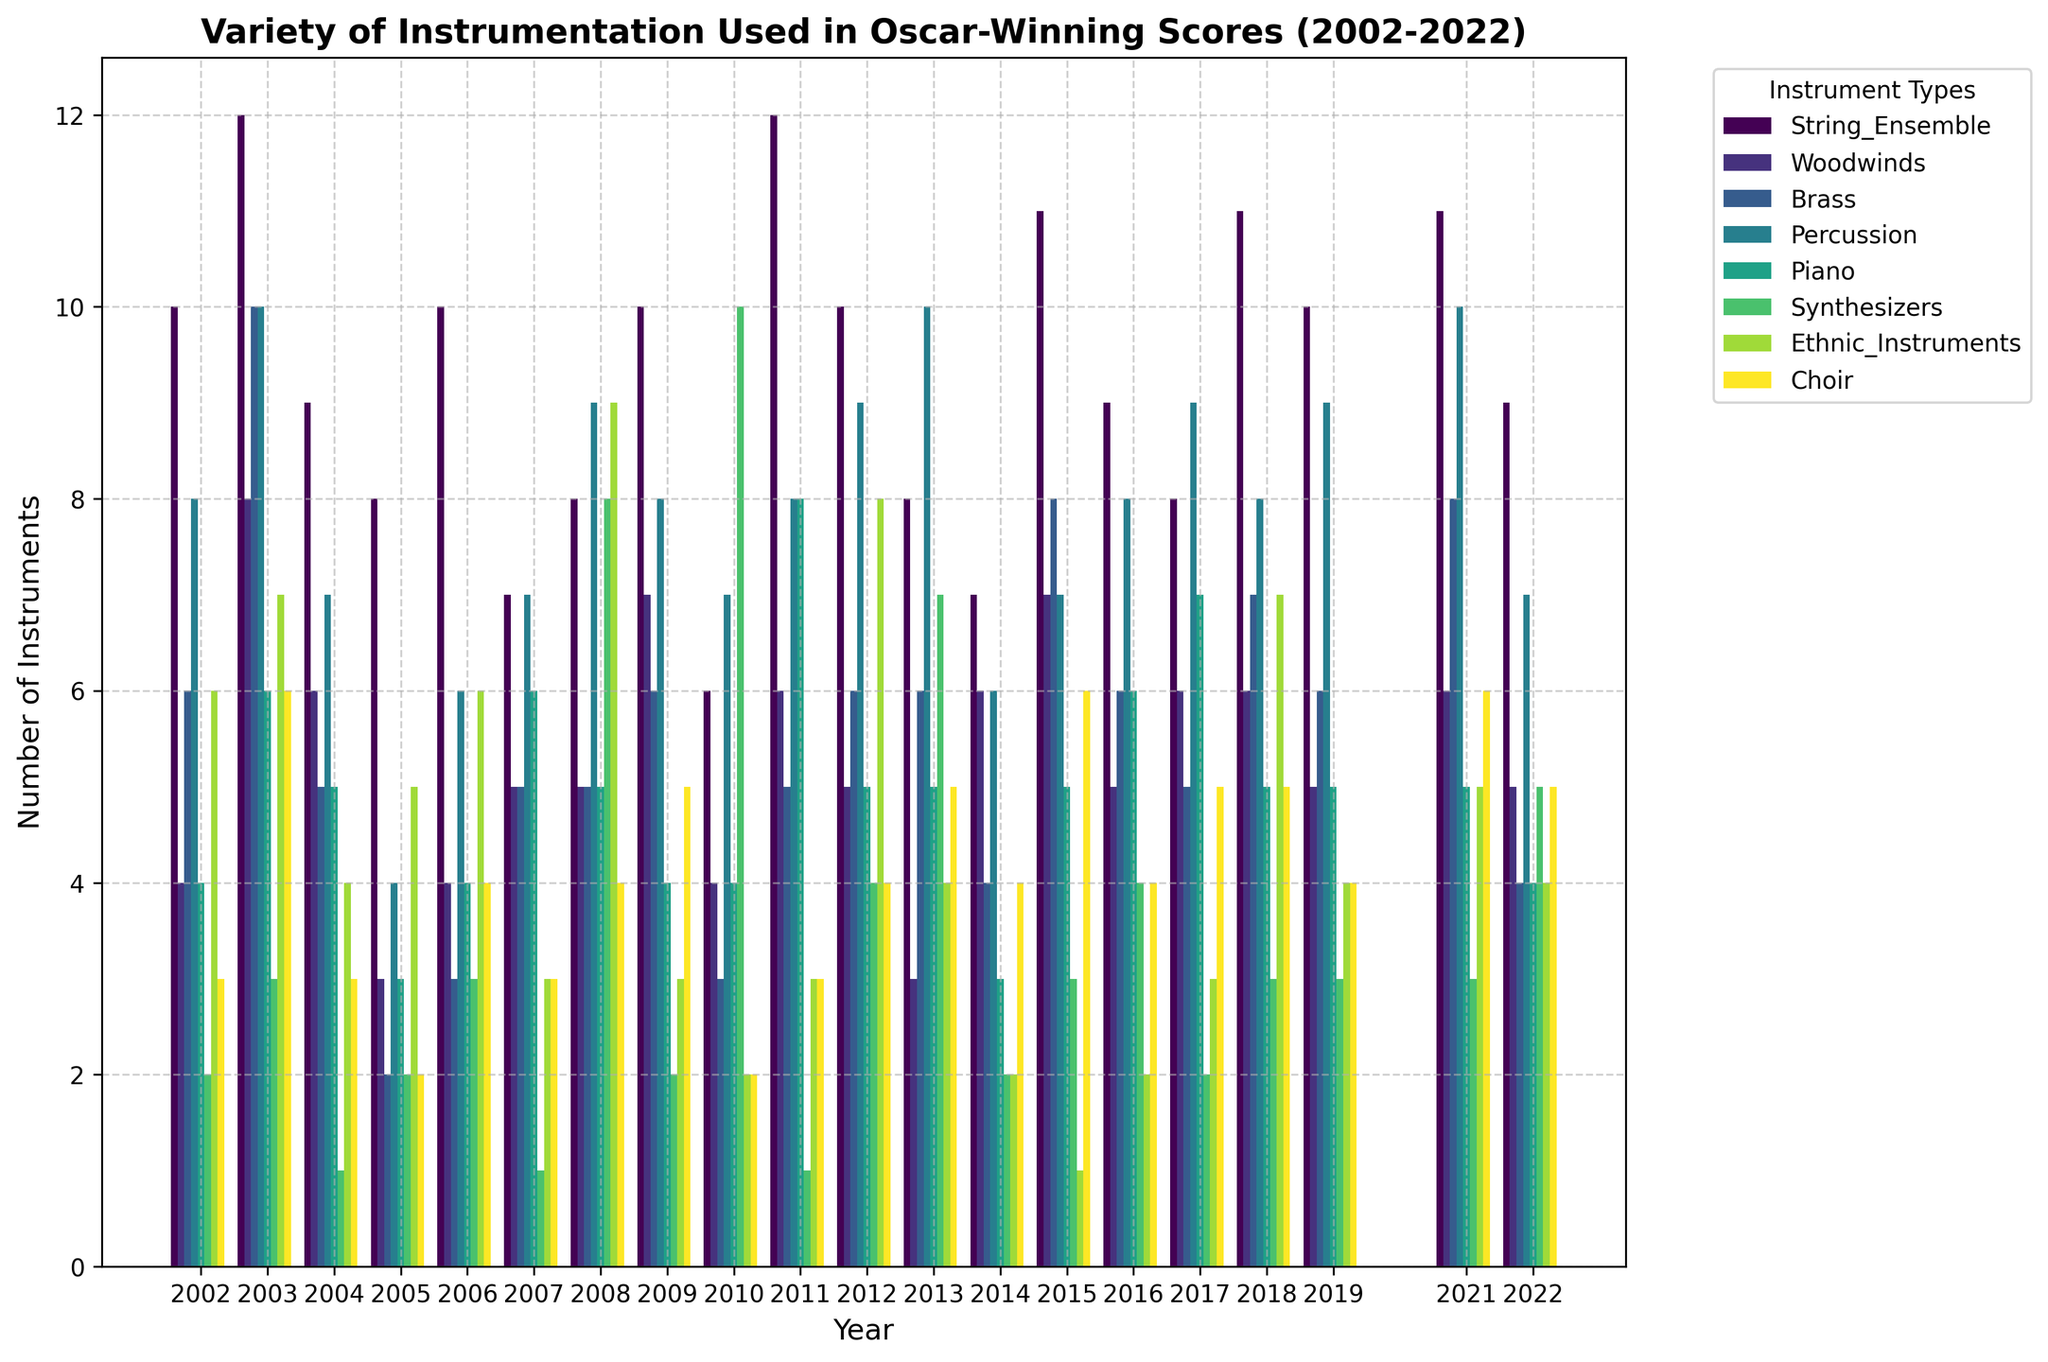What year had the highest number of string ensemble instruments? To find the year with the highest number of string ensemble instruments, look at the heights of the bars representing "String Ensemble" across all years. Identify the tallest bar and then locate its corresponding year on the x-axis.
Answer: 2003 How does the use of synthesizers in 2010 compare to 2008? Examine the height of the bars for "Synthesizers" in both 2010 and 2008. Compare which bar is taller to determine where more synthesizers were used.
Answer: 2010 > 2008 What is the total number of percussion instruments used in 2008 and 2017 combined? Identify the height of the "Percussion" bars for both 2008 and 2017. Sum these two heights to get the total. For 2008, it's 9, and for 2017, it's 9. Thus, 9 + 9 = 18.
Answer: 18 Which instrument type had the most consistent usage across the years? Look at the variations in bar heights for each instrument type over the years. The instrument type with the least variation (heights that look similar) is the most consistent.
Answer: Strings Between 2012 and 2014, which year saw a greater use of ethnic instruments? Look at the "Ethnic Instruments" bars for 2012 and 2014. Notice which bar is taller to determine the year with greater usage.
Answer: 2012 What's the average number of brass instruments used from 2002 to 2022? Find the height of the "Brass" bars for each year, sum these values, and divide by the number of years (17). For example, (6+10+5+2+3+5+5+6+3+5+6+6+4+8+6+7+8+6)/17 ≈ 5.35.
Answer: ~5.35 What is the difference in the number of woodwind instruments used in 2009 and 2018? Determine the heights of the "Woodwinds" bars in 2009 and 2018. Subtract the 2009 value from the 2018 value to find the difference (6-7 = -1).
Answer: -1 Which year had the highest variety of instrumentation (most bars of significant height)? Scan across all the years and identify the year where the largest numbers of different instrument types have taller bars.
Answer: 2003 